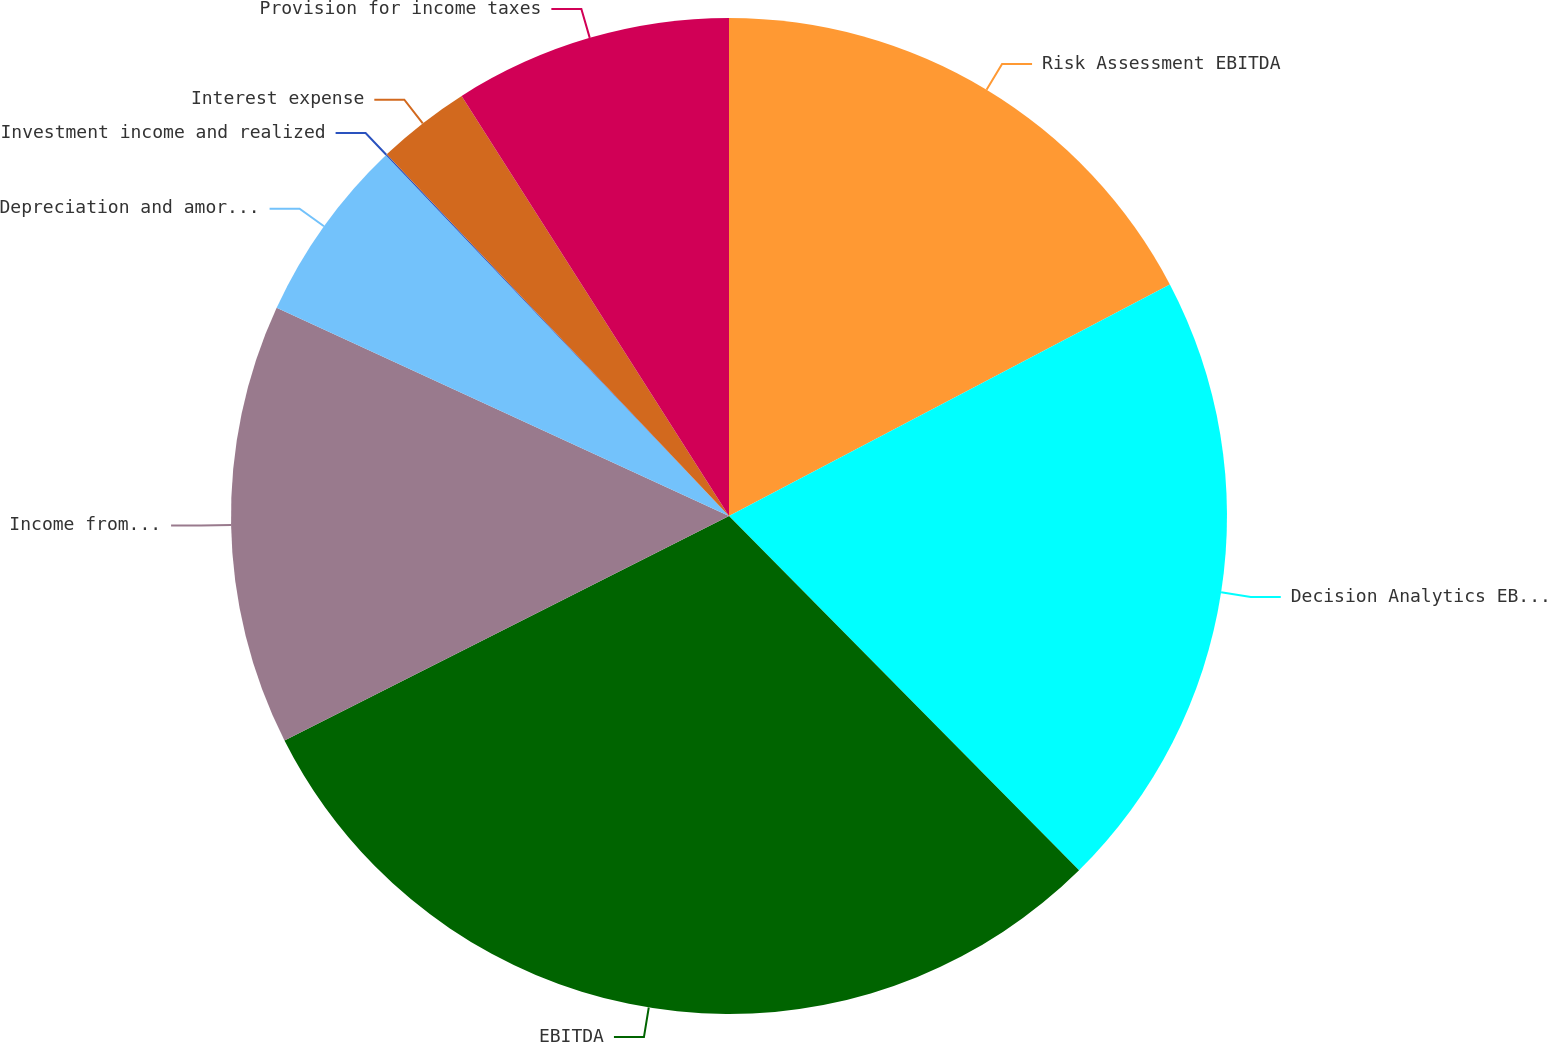Convert chart to OTSL. <chart><loc_0><loc_0><loc_500><loc_500><pie_chart><fcel>Risk Assessment EBITDA<fcel>Decision Analytics EBITDA<fcel>EBITDA<fcel>Income from continuing<fcel>Depreciation and amortization<fcel>Investment income and realized<fcel>Interest expense<fcel>Provision for income taxes<nl><fcel>17.3%<fcel>20.29%<fcel>29.96%<fcel>14.31%<fcel>6.03%<fcel>0.04%<fcel>3.04%<fcel>9.02%<nl></chart> 